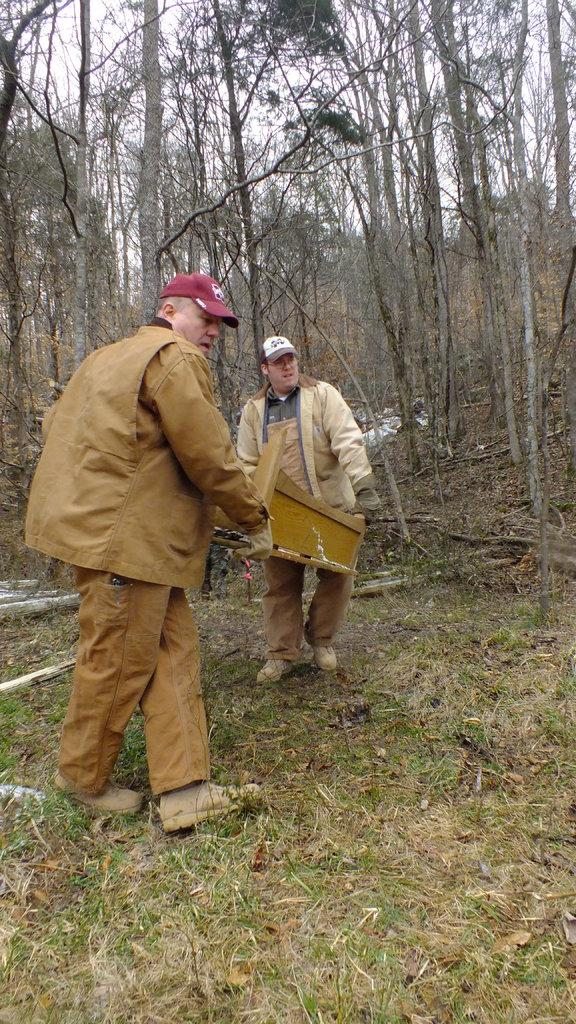How many people are in the image? There are two men in the image. What are the men wearing on their heads? The men are wearing caps. What are the men holding in their hands? The men are holding an object in their hands. What is the surface the men are walking on? The men are walking on the grass. What can be seen in the background of the image? There are sticks, trees, and the sky visible in the background of the image. What type of comfort can be seen in the image? There is no specific comfort depicted in the image; it features two men walking on the grass while wearing caps and holding an object. What is the men eating for lunch in the image? There is no lunch or eating activity depicted in the image; the men are holding an unspecified object. 